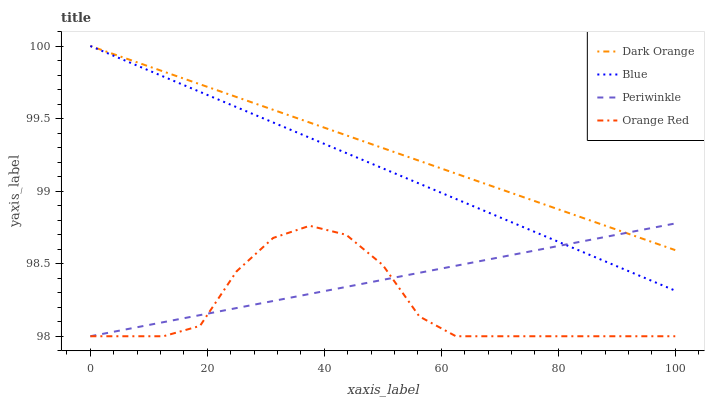Does Orange Red have the minimum area under the curve?
Answer yes or no. Yes. Does Dark Orange have the maximum area under the curve?
Answer yes or no. Yes. Does Periwinkle have the minimum area under the curve?
Answer yes or no. No. Does Periwinkle have the maximum area under the curve?
Answer yes or no. No. Is Blue the smoothest?
Answer yes or no. Yes. Is Orange Red the roughest?
Answer yes or no. Yes. Is Dark Orange the smoothest?
Answer yes or no. No. Is Dark Orange the roughest?
Answer yes or no. No. Does Periwinkle have the lowest value?
Answer yes or no. Yes. Does Dark Orange have the lowest value?
Answer yes or no. No. Does Dark Orange have the highest value?
Answer yes or no. Yes. Does Periwinkle have the highest value?
Answer yes or no. No. Is Orange Red less than Blue?
Answer yes or no. Yes. Is Dark Orange greater than Orange Red?
Answer yes or no. Yes. Does Blue intersect Dark Orange?
Answer yes or no. Yes. Is Blue less than Dark Orange?
Answer yes or no. No. Is Blue greater than Dark Orange?
Answer yes or no. No. Does Orange Red intersect Blue?
Answer yes or no. No. 